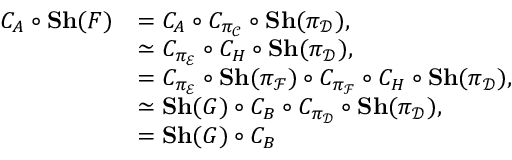Convert formula to latex. <formula><loc_0><loc_0><loc_500><loc_500>\begin{array} { r l } { C _ { A } \circ { S h } ( F ) } & { = C _ { A } \circ C _ { \pi _ { \mathcal { C } } } \circ { S h } ( \pi _ { \mathcal { D } } ) , } \\ & { \simeq C _ { \pi _ { \mathcal { E } } } \circ C _ { H } \circ { S h } ( \pi _ { \mathcal { D } } ) , } \\ & { = C _ { \pi _ { \mathcal { E } } } \circ { S h } ( \pi _ { \mathcal { F } } ) \circ C _ { \pi _ { \mathcal { F } } } \circ C _ { H } \circ { S h } ( \pi _ { \mathcal { D } } ) , } \\ & { \simeq { S h } ( G ) \circ C _ { B } \circ C _ { \pi _ { \mathcal { D } } } \circ { S h } ( \pi _ { \mathcal { D } } ) , } \\ & { = { S h } ( G ) \circ C _ { B } } \end{array}</formula> 